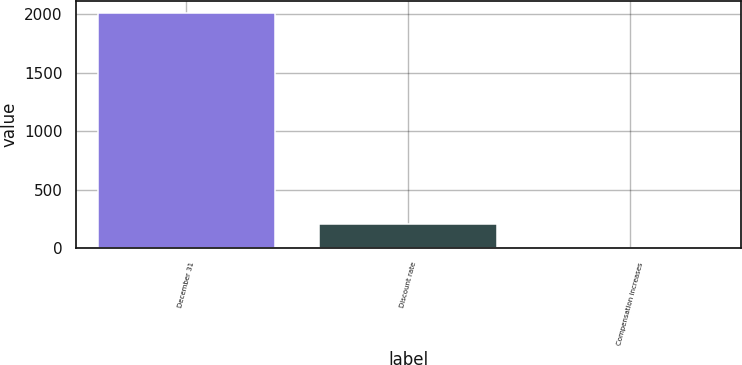Convert chart to OTSL. <chart><loc_0><loc_0><loc_500><loc_500><bar_chart><fcel>December 31<fcel>Discount rate<fcel>Compensation increases<nl><fcel>2015<fcel>204.92<fcel>3.8<nl></chart> 